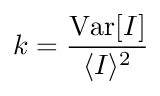Convert formula to latex. <formula><loc_0><loc_0><loc_500><loc_500>k = \frac { V a r [ I ] } { \langle I \rangle ^ { 2 } }</formula> 